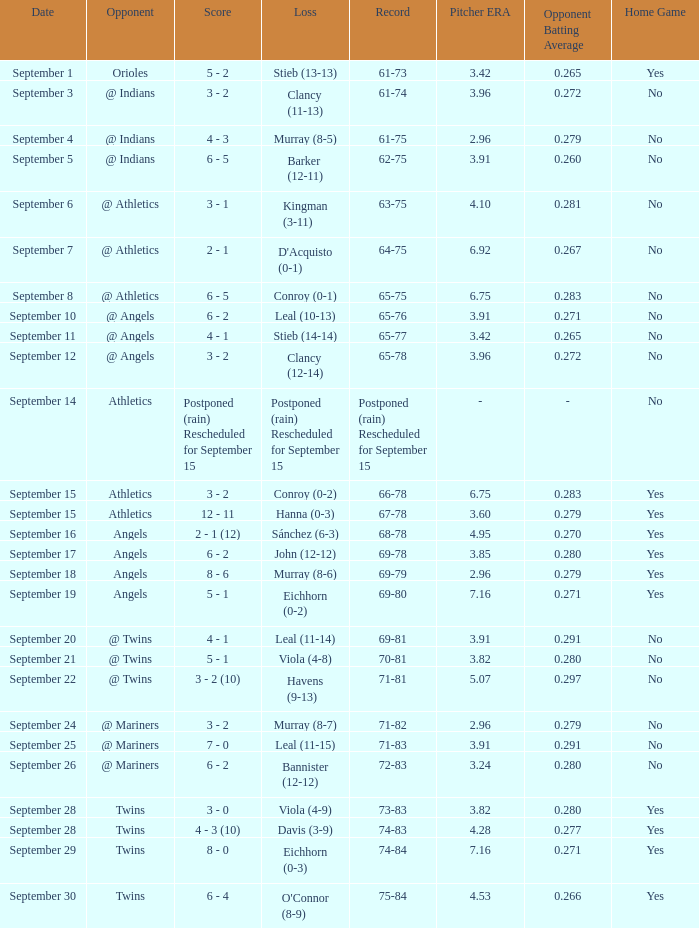Name the date for record of 74-84 September 29. 